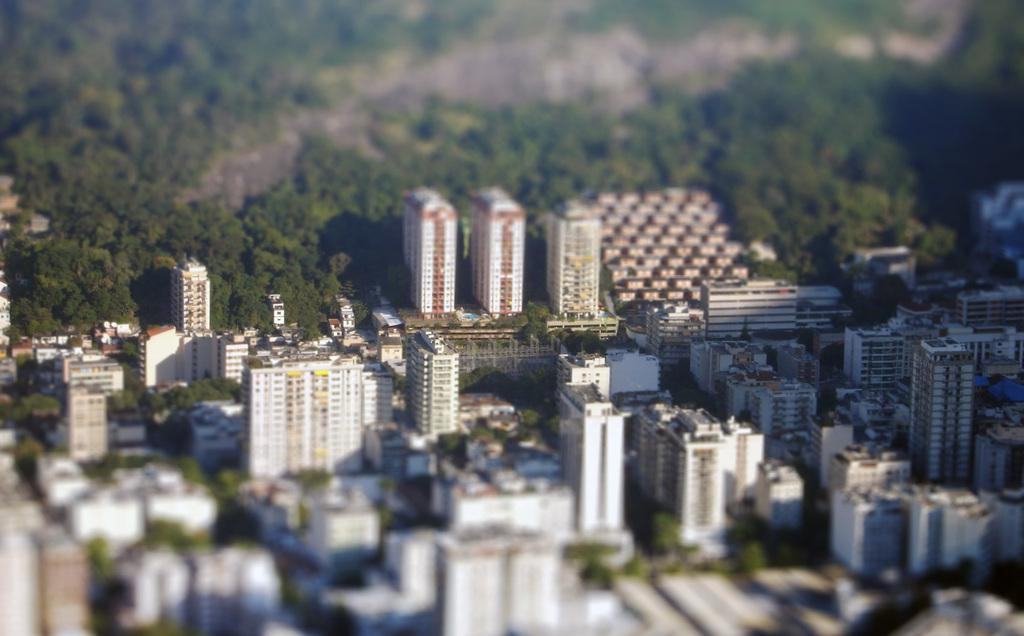What type of view is shown in the image? The image is an aerial view of a city. What can be seen on the land in the image? There are many buildings on the land in the image. How are the buildings distributed in the image? The buildings are spread out all over the place in the image. What can be seen in the background of the image? There are many trees in the background of the image. Can you see any dinosaurs roaming around in the city in the image? No, there are no dinosaurs present in the image; it shows a modern city with buildings and trees. 